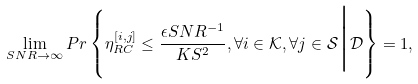Convert formula to latex. <formula><loc_0><loc_0><loc_500><loc_500>\lim _ { S N R \rightarrow \infty } P r \left \{ \eta ^ { [ i , j ] } _ { R C } \leq \frac { \epsilon S N R ^ { - 1 } } { K S ^ { 2 } } , \forall i \in \mathcal { K } , \forall j \in \mathcal { S } \Big | \mathcal { D } \right \} = 1 ,</formula> 